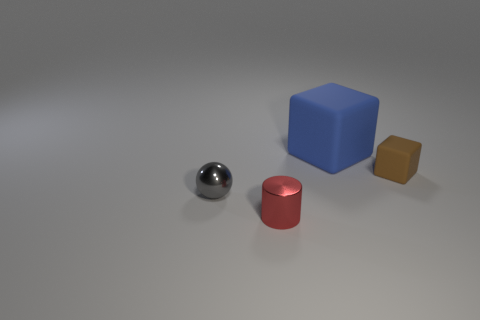What color is the matte block that is the same size as the red object?
Ensure brevity in your answer.  Brown. What number of things are either tiny things on the right side of the large object or tiny brown balls?
Offer a very short reply. 1. The small object behind the metal object on the left side of the tiny red metal thing is made of what material?
Ensure brevity in your answer.  Rubber. Are there any big brown things that have the same material as the red object?
Make the answer very short. No. Are there any rubber things that are in front of the tiny shiny object on the right side of the gray metallic ball?
Your response must be concise. No. What is the object that is left of the tiny red shiny object made of?
Ensure brevity in your answer.  Metal. Does the big rubber thing have the same shape as the tiny gray object?
Ensure brevity in your answer.  No. What color is the small metallic object that is right of the small metal thing behind the object in front of the gray object?
Give a very brief answer. Red. How many other small matte things have the same shape as the tiny brown object?
Your answer should be compact. 0. There is a rubber object that is left of the small object that is right of the small red metal cylinder; what size is it?
Provide a short and direct response. Large. 